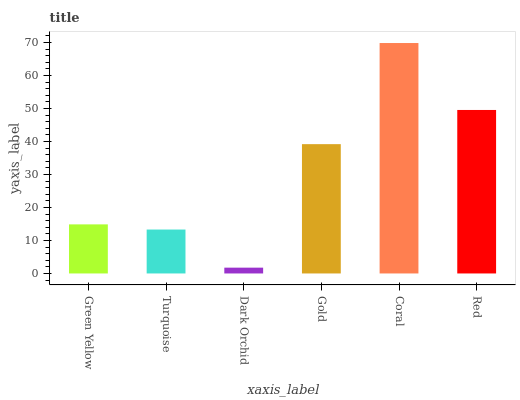Is Turquoise the minimum?
Answer yes or no. No. Is Turquoise the maximum?
Answer yes or no. No. Is Green Yellow greater than Turquoise?
Answer yes or no. Yes. Is Turquoise less than Green Yellow?
Answer yes or no. Yes. Is Turquoise greater than Green Yellow?
Answer yes or no. No. Is Green Yellow less than Turquoise?
Answer yes or no. No. Is Gold the high median?
Answer yes or no. Yes. Is Green Yellow the low median?
Answer yes or no. Yes. Is Dark Orchid the high median?
Answer yes or no. No. Is Dark Orchid the low median?
Answer yes or no. No. 